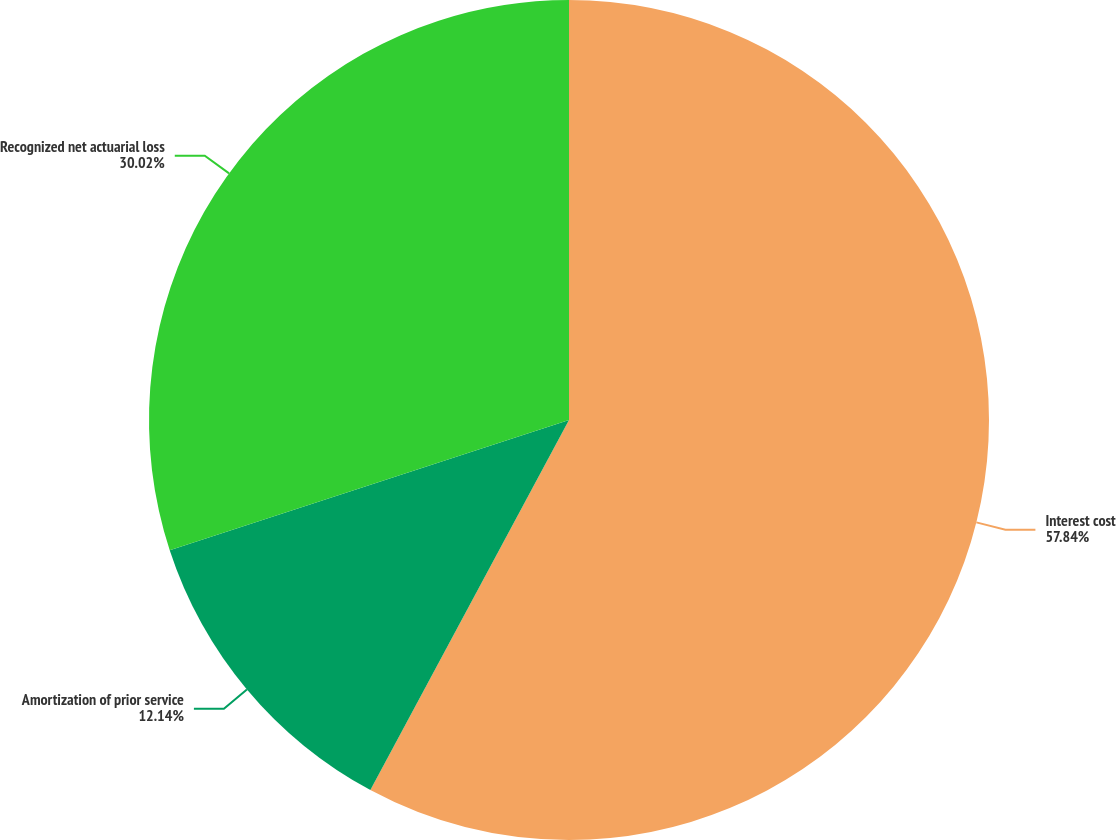Convert chart. <chart><loc_0><loc_0><loc_500><loc_500><pie_chart><fcel>Interest cost<fcel>Amortization of prior service<fcel>Recognized net actuarial loss<nl><fcel>57.84%<fcel>12.14%<fcel>30.02%<nl></chart> 